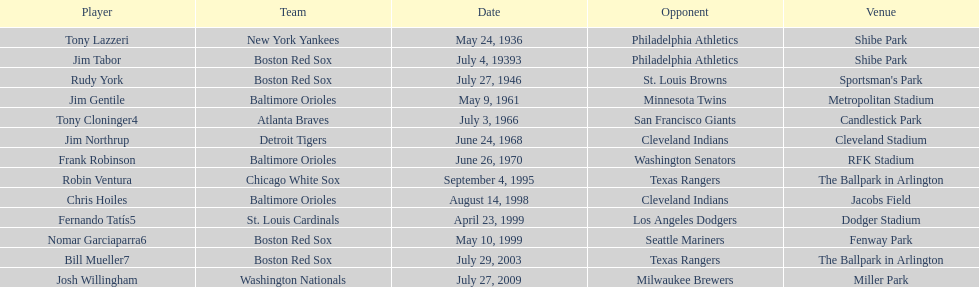Up until now, who was the final person to manage accomplishing this? Josh Willingham. 